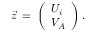<formula> <loc_0><loc_0><loc_500><loc_500>{ \vec { z } } \, = \, \left ( \begin{array} { l } { { U _ { i } } } \\ { { V _ { A } } } \end{array} \right ) .</formula> 